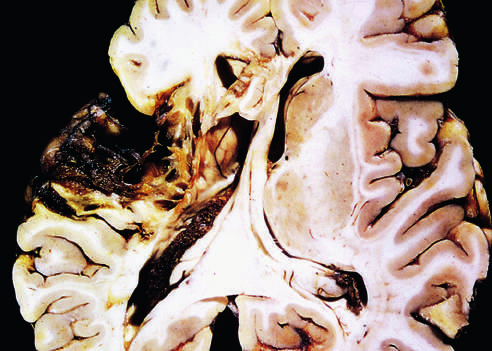what shows destruction of cortex and surrounding gliosis?
Answer the question using a single word or phrase. Old cystic infarct 